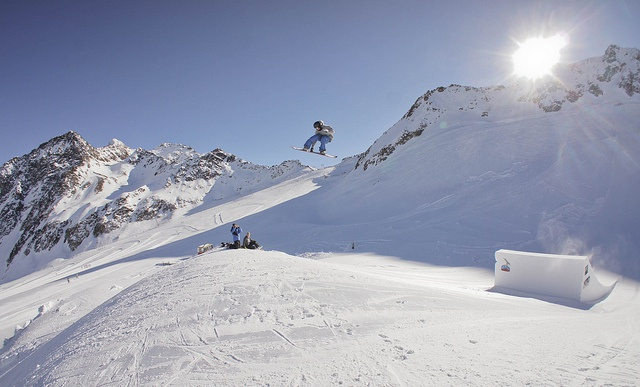Describe the objects in this image and their specific colors. I can see people in darkblue, gray, blue, black, and darkgray tones, people in darkblue, black, gray, and darkgray tones, people in darkblue, black, blue, navy, and gray tones, and snowboard in darkblue, darkgray, gray, and lightgray tones in this image. 